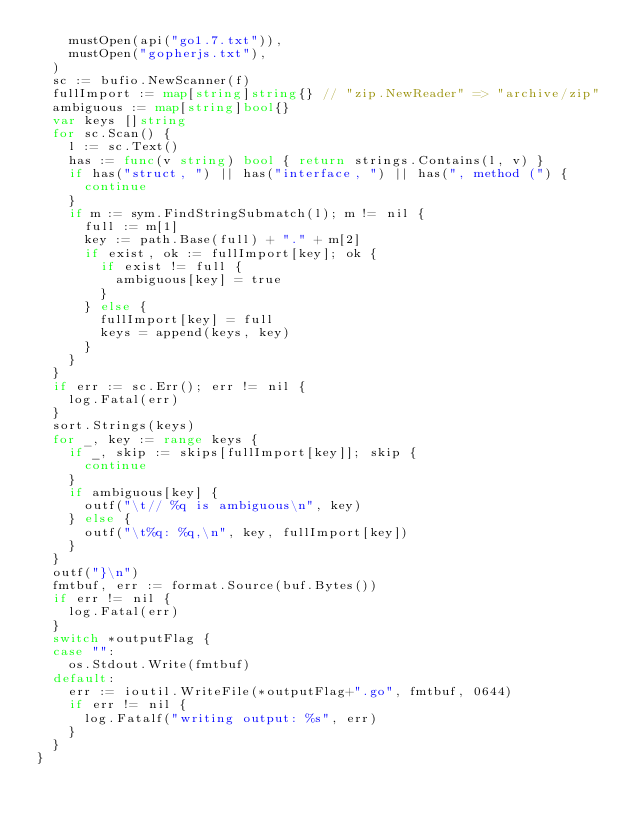Convert code to text. <code><loc_0><loc_0><loc_500><loc_500><_Go_>		mustOpen(api("go1.7.txt")),
		mustOpen("gopherjs.txt"),
	)
	sc := bufio.NewScanner(f)
	fullImport := map[string]string{} // "zip.NewReader" => "archive/zip"
	ambiguous := map[string]bool{}
	var keys []string
	for sc.Scan() {
		l := sc.Text()
		has := func(v string) bool { return strings.Contains(l, v) }
		if has("struct, ") || has("interface, ") || has(", method (") {
			continue
		}
		if m := sym.FindStringSubmatch(l); m != nil {
			full := m[1]
			key := path.Base(full) + "." + m[2]
			if exist, ok := fullImport[key]; ok {
				if exist != full {
					ambiguous[key] = true
				}
			} else {
				fullImport[key] = full
				keys = append(keys, key)
			}
		}
	}
	if err := sc.Err(); err != nil {
		log.Fatal(err)
	}
	sort.Strings(keys)
	for _, key := range keys {
		if _, skip := skips[fullImport[key]]; skip {
			continue
		}
		if ambiguous[key] {
			outf("\t// %q is ambiguous\n", key)
		} else {
			outf("\t%q: %q,\n", key, fullImport[key])
		}
	}
	outf("}\n")
	fmtbuf, err := format.Source(buf.Bytes())
	if err != nil {
		log.Fatal(err)
	}
	switch *outputFlag {
	case "":
		os.Stdout.Write(fmtbuf)
	default:
		err := ioutil.WriteFile(*outputFlag+".go", fmtbuf, 0644)
		if err != nil {
			log.Fatalf("writing output: %s", err)
		}
	}
}
</code> 